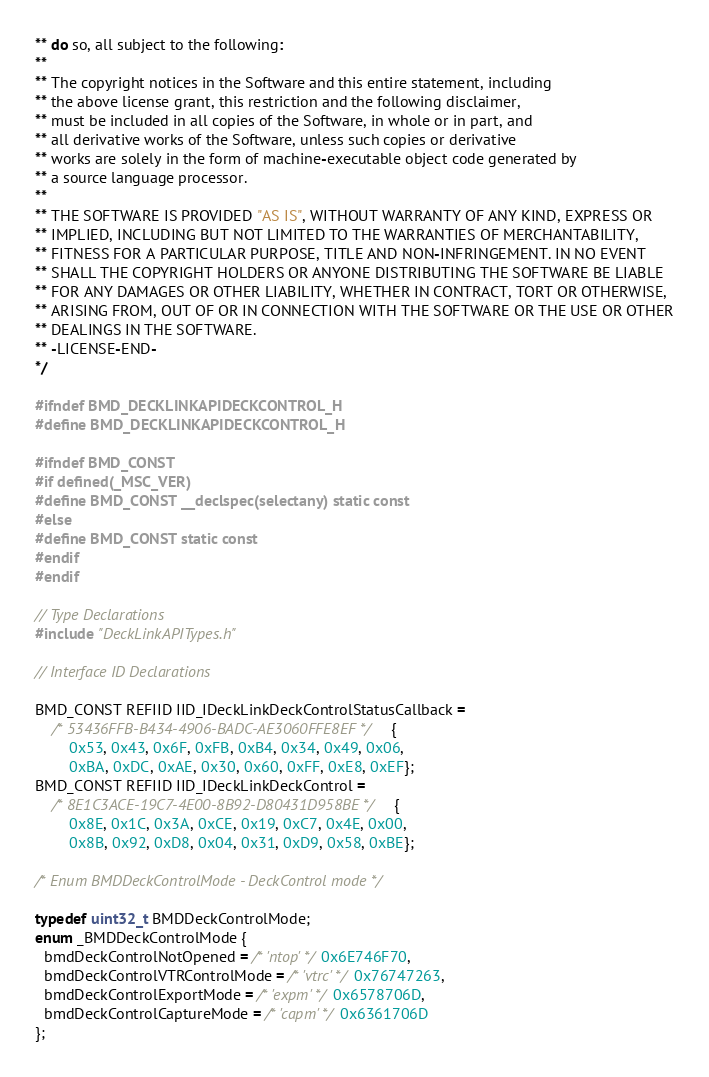<code> <loc_0><loc_0><loc_500><loc_500><_C_>** do so, all subject to the following:
**
** The copyright notices in the Software and this entire statement, including
** the above license grant, this restriction and the following disclaimer,
** must be included in all copies of the Software, in whole or in part, and
** all derivative works of the Software, unless such copies or derivative
** works are solely in the form of machine-executable object code generated by
** a source language processor.
**
** THE SOFTWARE IS PROVIDED "AS IS", WITHOUT WARRANTY OF ANY KIND, EXPRESS OR
** IMPLIED, INCLUDING BUT NOT LIMITED TO THE WARRANTIES OF MERCHANTABILITY,
** FITNESS FOR A PARTICULAR PURPOSE, TITLE AND NON-INFRINGEMENT. IN NO EVENT
** SHALL THE COPYRIGHT HOLDERS OR ANYONE DISTRIBUTING THE SOFTWARE BE LIABLE
** FOR ANY DAMAGES OR OTHER LIABILITY, WHETHER IN CONTRACT, TORT OR OTHERWISE,
** ARISING FROM, OUT OF OR IN CONNECTION WITH THE SOFTWARE OR THE USE OR OTHER
** DEALINGS IN THE SOFTWARE.
** -LICENSE-END-
*/

#ifndef BMD_DECKLINKAPIDECKCONTROL_H
#define BMD_DECKLINKAPIDECKCONTROL_H

#ifndef BMD_CONST
#if defined(_MSC_VER)
#define BMD_CONST __declspec(selectany) static const
#else
#define BMD_CONST static const
#endif
#endif

// Type Declarations
#include "DeckLinkAPITypes.h"

// Interface ID Declarations

BMD_CONST REFIID IID_IDeckLinkDeckControlStatusCallback =
    /* 53436FFB-B434-4906-BADC-AE3060FFE8EF */ {
        0x53, 0x43, 0x6F, 0xFB, 0xB4, 0x34, 0x49, 0x06,
        0xBA, 0xDC, 0xAE, 0x30, 0x60, 0xFF, 0xE8, 0xEF};
BMD_CONST REFIID IID_IDeckLinkDeckControl =
    /* 8E1C3ACE-19C7-4E00-8B92-D80431D958BE */ {
        0x8E, 0x1C, 0x3A, 0xCE, 0x19, 0xC7, 0x4E, 0x00,
        0x8B, 0x92, 0xD8, 0x04, 0x31, 0xD9, 0x58, 0xBE};

/* Enum BMDDeckControlMode - DeckControl mode */

typedef uint32_t BMDDeckControlMode;
enum _BMDDeckControlMode {
  bmdDeckControlNotOpened = /* 'ntop' */ 0x6E746F70,
  bmdDeckControlVTRControlMode = /* 'vtrc' */ 0x76747263,
  bmdDeckControlExportMode = /* 'expm' */ 0x6578706D,
  bmdDeckControlCaptureMode = /* 'capm' */ 0x6361706D
};
</code> 